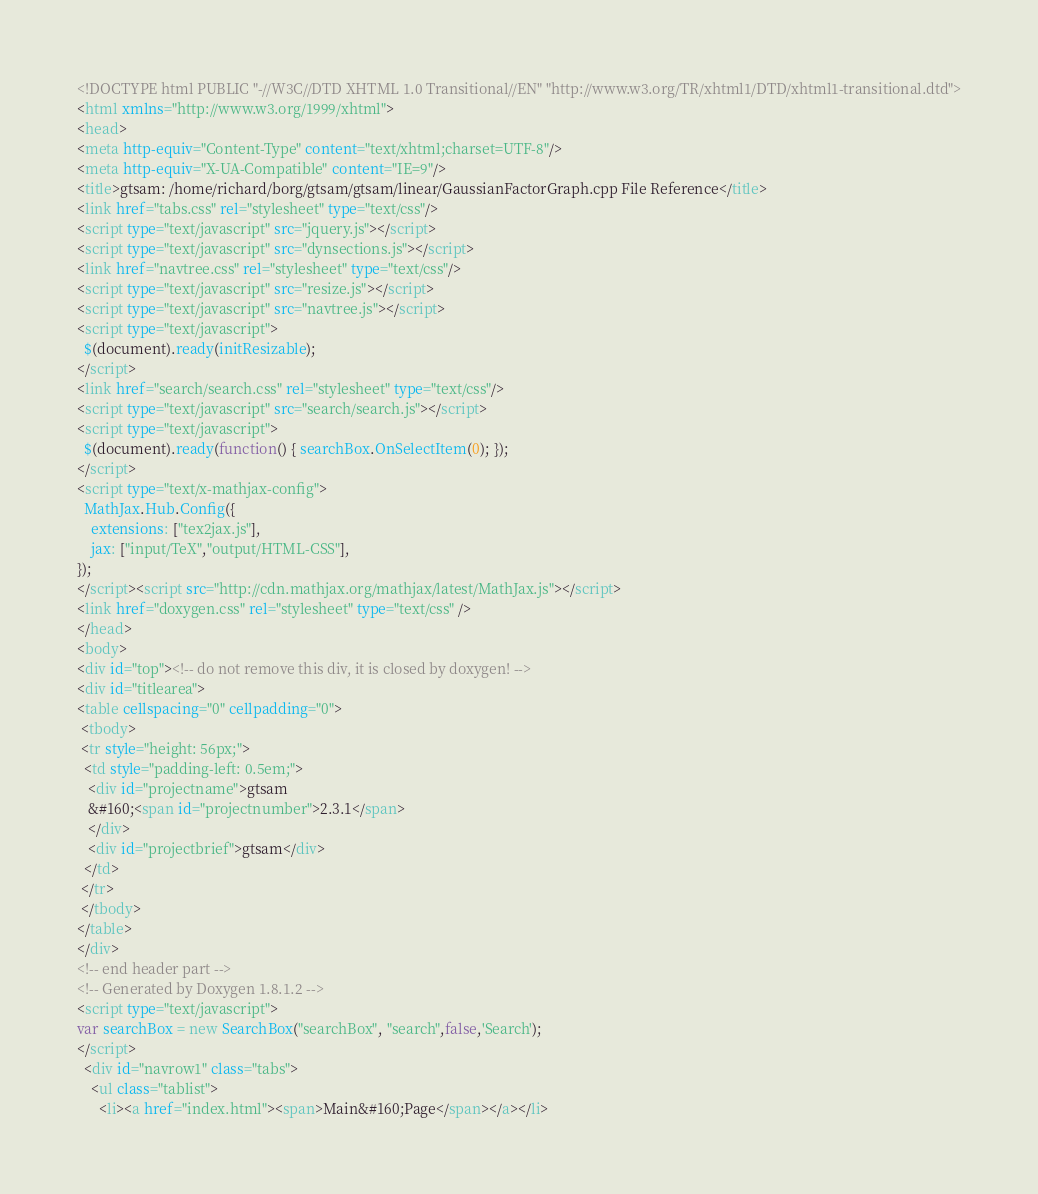Convert code to text. <code><loc_0><loc_0><loc_500><loc_500><_HTML_><!DOCTYPE html PUBLIC "-//W3C//DTD XHTML 1.0 Transitional//EN" "http://www.w3.org/TR/xhtml1/DTD/xhtml1-transitional.dtd">
<html xmlns="http://www.w3.org/1999/xhtml">
<head>
<meta http-equiv="Content-Type" content="text/xhtml;charset=UTF-8"/>
<meta http-equiv="X-UA-Compatible" content="IE=9"/>
<title>gtsam: /home/richard/borg/gtsam/gtsam/linear/GaussianFactorGraph.cpp File Reference</title>
<link href="tabs.css" rel="stylesheet" type="text/css"/>
<script type="text/javascript" src="jquery.js"></script>
<script type="text/javascript" src="dynsections.js"></script>
<link href="navtree.css" rel="stylesheet" type="text/css"/>
<script type="text/javascript" src="resize.js"></script>
<script type="text/javascript" src="navtree.js"></script>
<script type="text/javascript">
  $(document).ready(initResizable);
</script>
<link href="search/search.css" rel="stylesheet" type="text/css"/>
<script type="text/javascript" src="search/search.js"></script>
<script type="text/javascript">
  $(document).ready(function() { searchBox.OnSelectItem(0); });
</script>
<script type="text/x-mathjax-config">
  MathJax.Hub.Config({
    extensions: ["tex2jax.js"],
    jax: ["input/TeX","output/HTML-CSS"],
});
</script><script src="http://cdn.mathjax.org/mathjax/latest/MathJax.js"></script>
<link href="doxygen.css" rel="stylesheet" type="text/css" />
</head>
<body>
<div id="top"><!-- do not remove this div, it is closed by doxygen! -->
<div id="titlearea">
<table cellspacing="0" cellpadding="0">
 <tbody>
 <tr style="height: 56px;">
  <td style="padding-left: 0.5em;">
   <div id="projectname">gtsam
   &#160;<span id="projectnumber">2.3.1</span>
   </div>
   <div id="projectbrief">gtsam</div>
  </td>
 </tr>
 </tbody>
</table>
</div>
<!-- end header part -->
<!-- Generated by Doxygen 1.8.1.2 -->
<script type="text/javascript">
var searchBox = new SearchBox("searchBox", "search",false,'Search');
</script>
  <div id="navrow1" class="tabs">
    <ul class="tablist">
      <li><a href="index.html"><span>Main&#160;Page</span></a></li></code> 